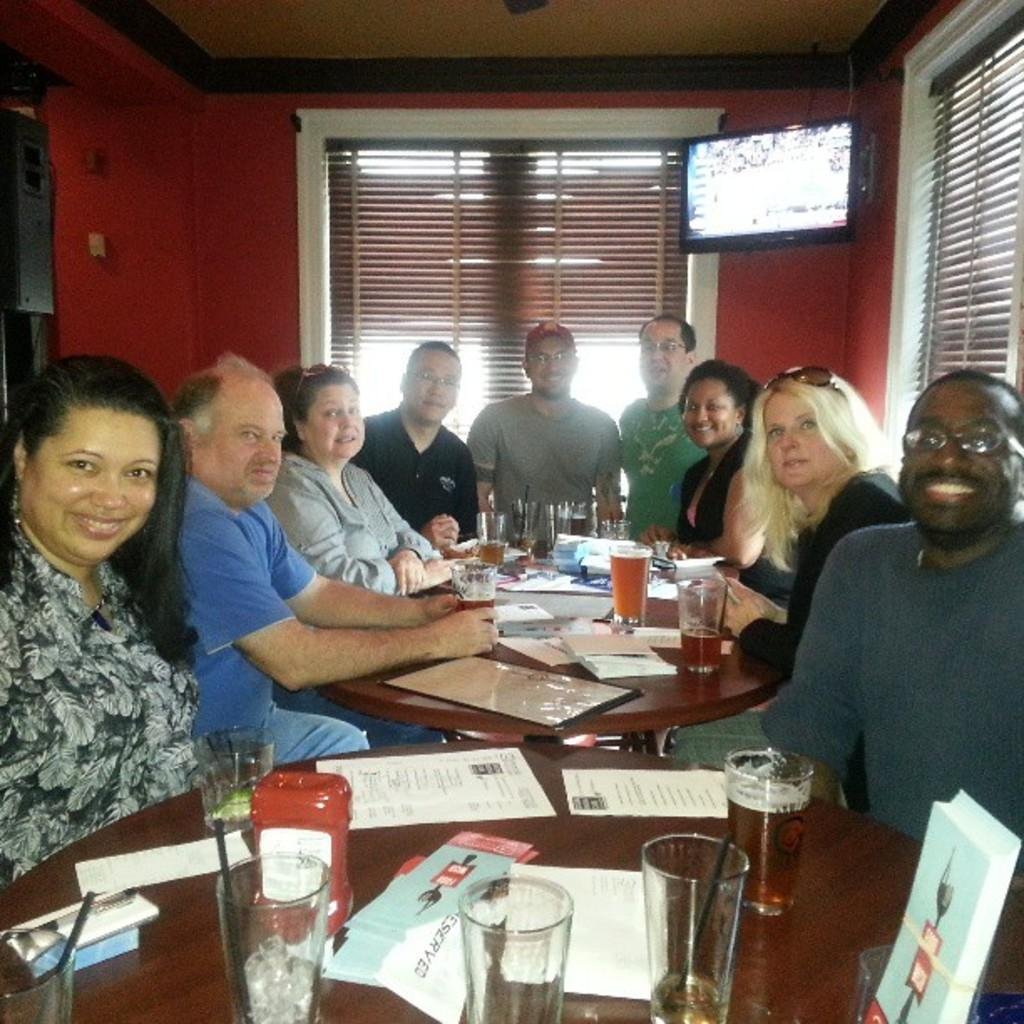What are the people in the image doing? The people in the image are sitting in chairs. Where are the people located in relation to the table? The people are in front of a table. What can be found on the table in the image? There are various items on the table. What type of mouth can be seen on the man in the image? There is no man present in the image, and therefore no mouth to observe. 